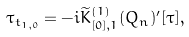<formula> <loc_0><loc_0><loc_500><loc_500>\tau _ { t _ { 1 , 0 } } = - i \widetilde { K } ^ { ( 1 ) } _ { [ 0 ] , 1 } ( Q _ { n } ) ^ { \prime } [ \tau ] ,</formula> 